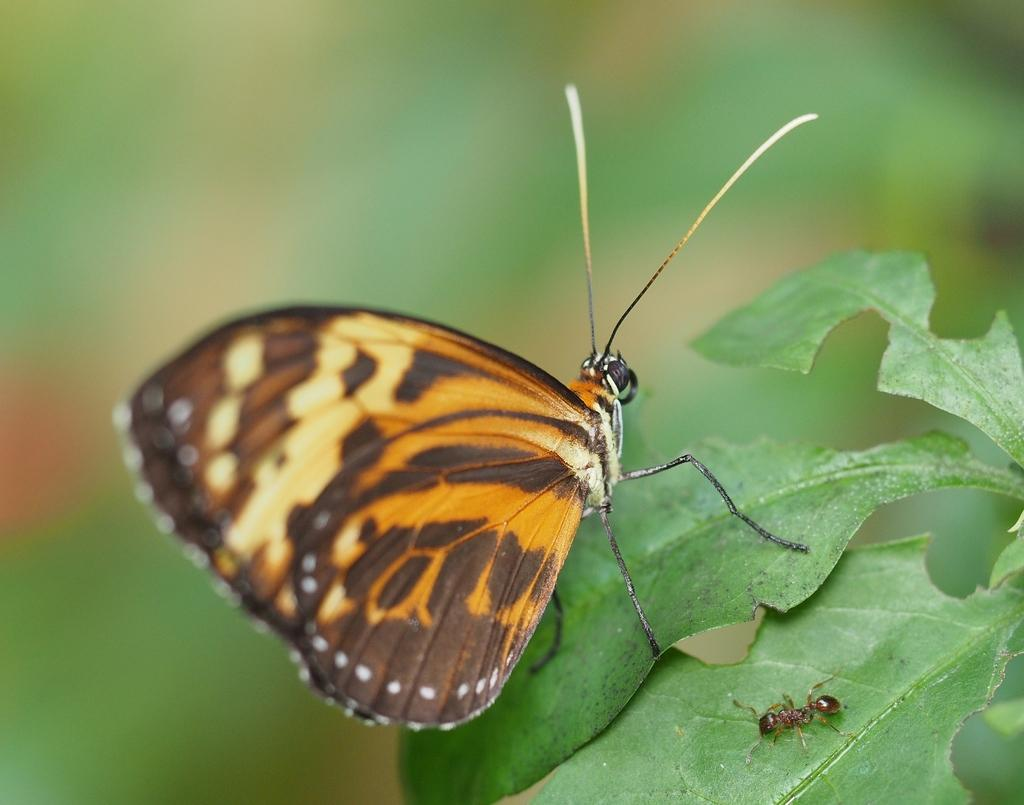What is located in the center of the image? There are leaves in the center of the image. What insects can be seen on the leaves? There is an ant and a butterfly on the leaves. Can you describe the butterfly's appearance? The butterfly is black and yellow in color. How many cows are visible in the image? There are no cows present in the image; it features leaves, an ant, and a butterfly. 